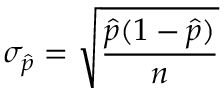<formula> <loc_0><loc_0><loc_500><loc_500>\sigma _ { \hat { p } } = { \sqrt { \frac { { \hat { p } } ( 1 - { \hat { p } } ) } { n } } }</formula> 